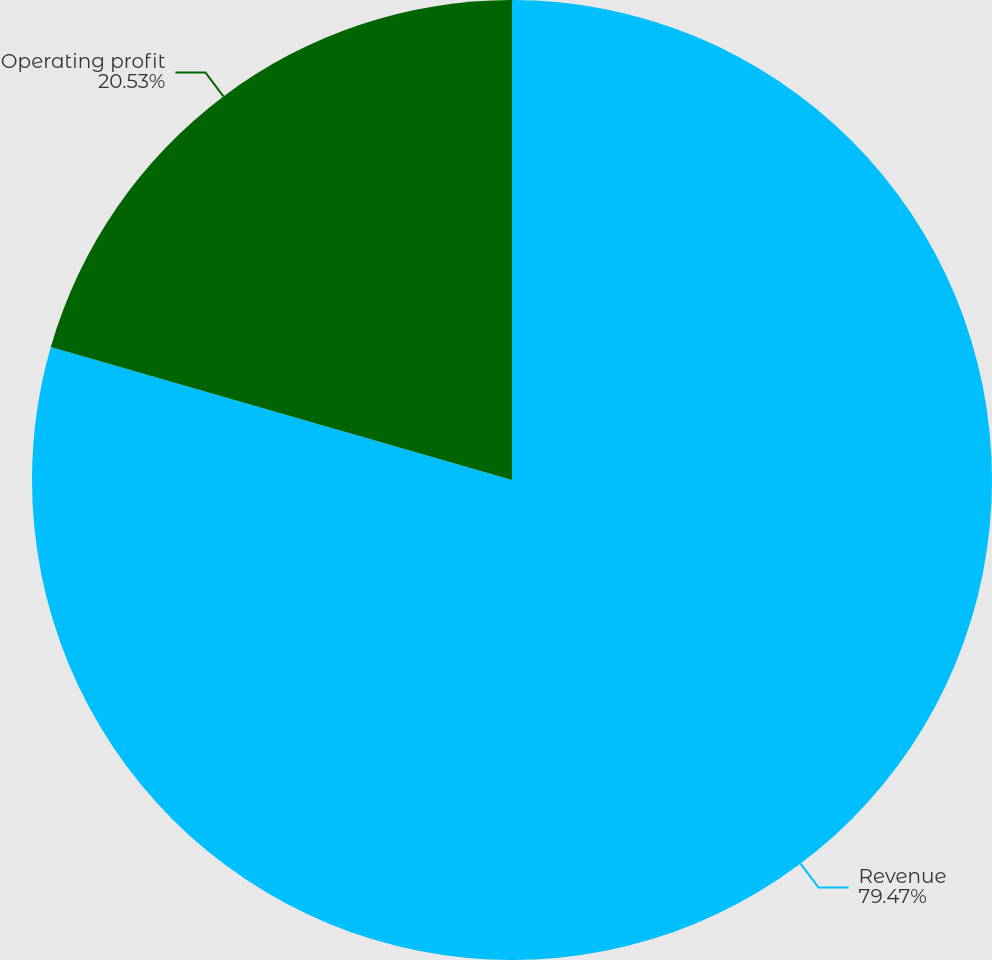Convert chart. <chart><loc_0><loc_0><loc_500><loc_500><pie_chart><fcel>Revenue<fcel>Operating profit<nl><fcel>79.47%<fcel>20.53%<nl></chart> 